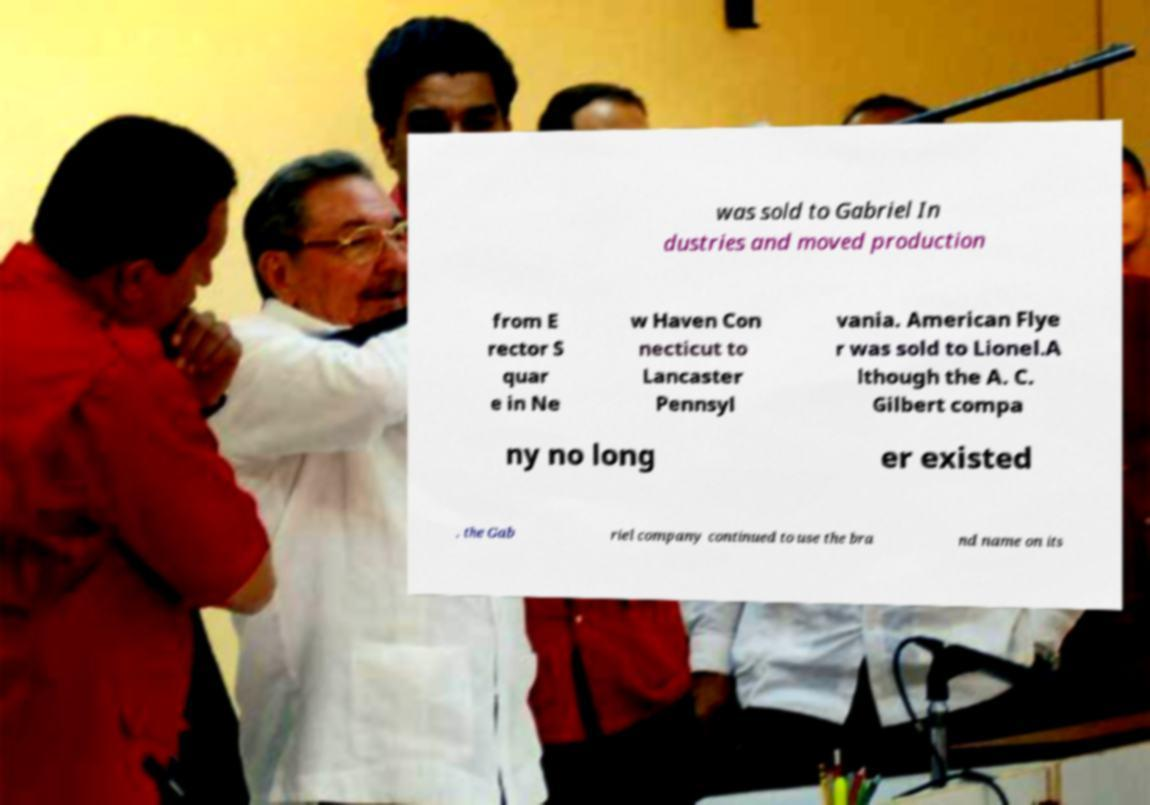There's text embedded in this image that I need extracted. Can you transcribe it verbatim? was sold to Gabriel In dustries and moved production from E rector S quar e in Ne w Haven Con necticut to Lancaster Pennsyl vania. American Flye r was sold to Lionel.A lthough the A. C. Gilbert compa ny no long er existed , the Gab riel company continued to use the bra nd name on its 